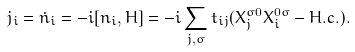Convert formula to latex. <formula><loc_0><loc_0><loc_500><loc_500>j _ { i } = { \dot { n } _ { i } } = - i [ n _ { i } , H ] = - i \sum _ { j , \sigma } t _ { i j } ( X _ { j } ^ { \sigma 0 } X _ { i } ^ { 0 \sigma } - H . c . ) .</formula> 